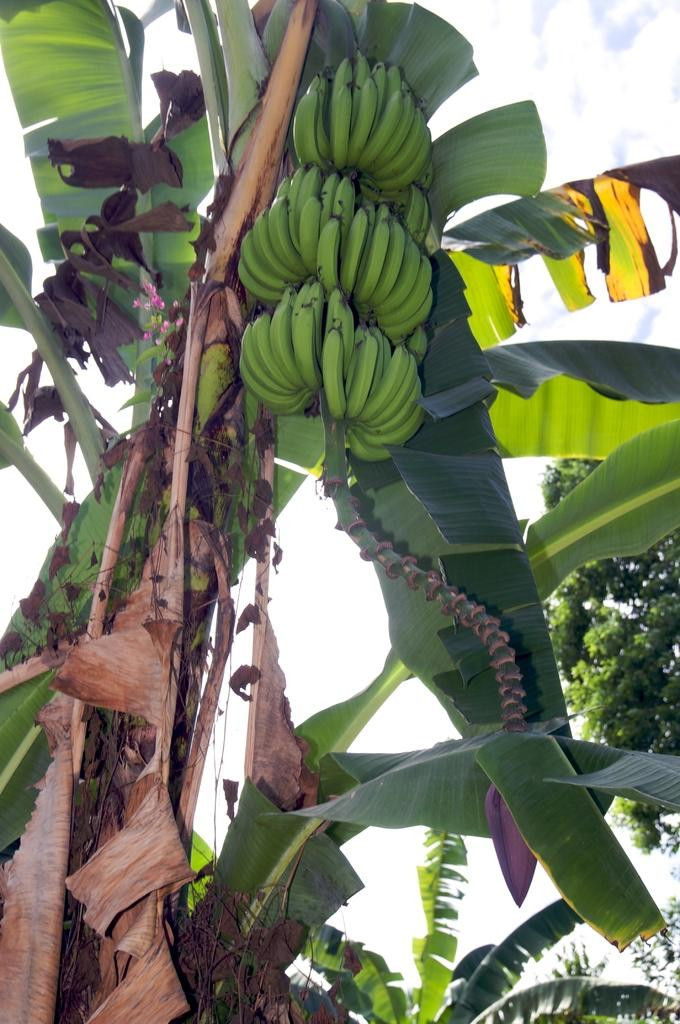What type of tree is present in the image? There is a banana tree in the image. What can be found on the banana tree? There are bananas on the tree. Can you describe the background of the image? There is another tree visible in the background of the image. What channel is the banana tree tuned to in the image? There is no indication that the banana tree is tuned to a channel, as trees do not have the ability to tune into channels. 